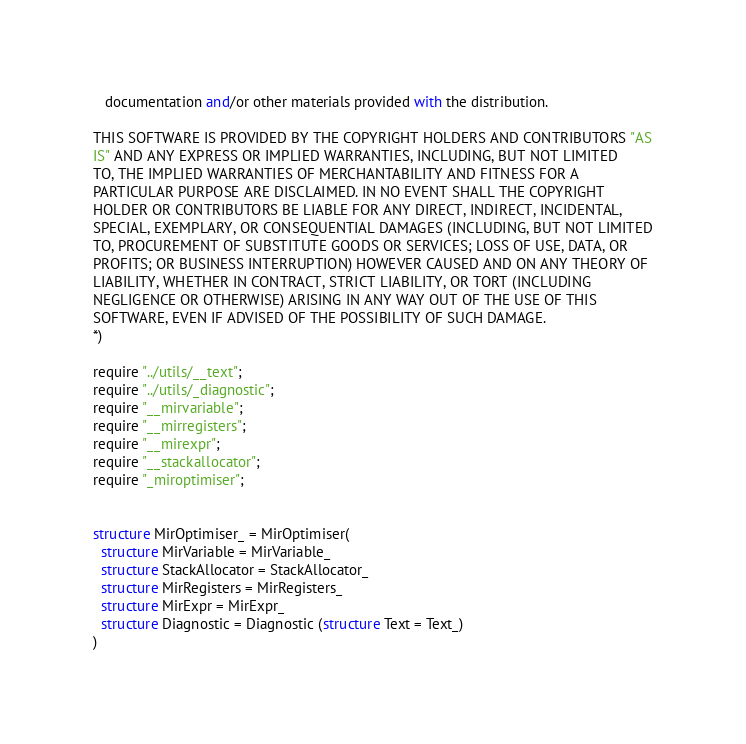<code> <loc_0><loc_0><loc_500><loc_500><_SML_>   documentation and/or other materials provided with the distribution.

THIS SOFTWARE IS PROVIDED BY THE COPYRIGHT HOLDERS AND CONTRIBUTORS "AS
IS" AND ANY EXPRESS OR IMPLIED WARRANTIES, INCLUDING, BUT NOT LIMITED
TO, THE IMPLIED WARRANTIES OF MERCHANTABILITY AND FITNESS FOR A
PARTICULAR PURPOSE ARE DISCLAIMED. IN NO EVENT SHALL THE COPYRIGHT
HOLDER OR CONTRIBUTORS BE LIABLE FOR ANY DIRECT, INDIRECT, INCIDENTAL,
SPECIAL, EXEMPLARY, OR CONSEQUENTIAL DAMAGES (INCLUDING, BUT NOT LIMITED
TO, PROCUREMENT OF SUBSTITUTE GOODS OR SERVICES; LOSS OF USE, DATA, OR
PROFITS; OR BUSINESS INTERRUPTION) HOWEVER CAUSED AND ON ANY THEORY OF
LIABILITY, WHETHER IN CONTRACT, STRICT LIABILITY, OR TORT (INCLUDING
NEGLIGENCE OR OTHERWISE) ARISING IN ANY WAY OUT OF THE USE OF THIS
SOFTWARE, EVEN IF ADVISED OF THE POSSIBILITY OF SUCH DAMAGE.
*)

require "../utils/__text";
require "../utils/_diagnostic";
require "__mirvariable";
require "__mirregisters";
require "__mirexpr";
require "__stackallocator";
require "_miroptimiser";


structure MirOptimiser_ = MirOptimiser(
  structure MirVariable = MirVariable_
  structure StackAllocator = StackAllocator_
  structure MirRegisters = MirRegisters_
  structure MirExpr = MirExpr_
  structure Diagnostic = Diagnostic (structure Text = Text_)
)
</code> 